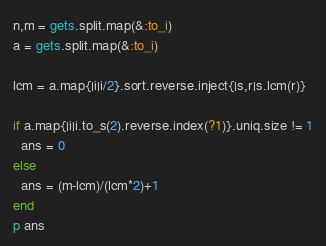<code> <loc_0><loc_0><loc_500><loc_500><_Ruby_>n,m = gets.split.map(&:to_i)
a = gets.split.map(&:to_i)

lcm = a.map{|i|i/2}.sort.reverse.inject{|s,r|s.lcm(r)}

if a.map{|i|i.to_s(2).reverse.index(?1)}.uniq.size != 1
  ans = 0
else
  ans = (m-lcm)/(lcm*2)+1
end
p ans</code> 